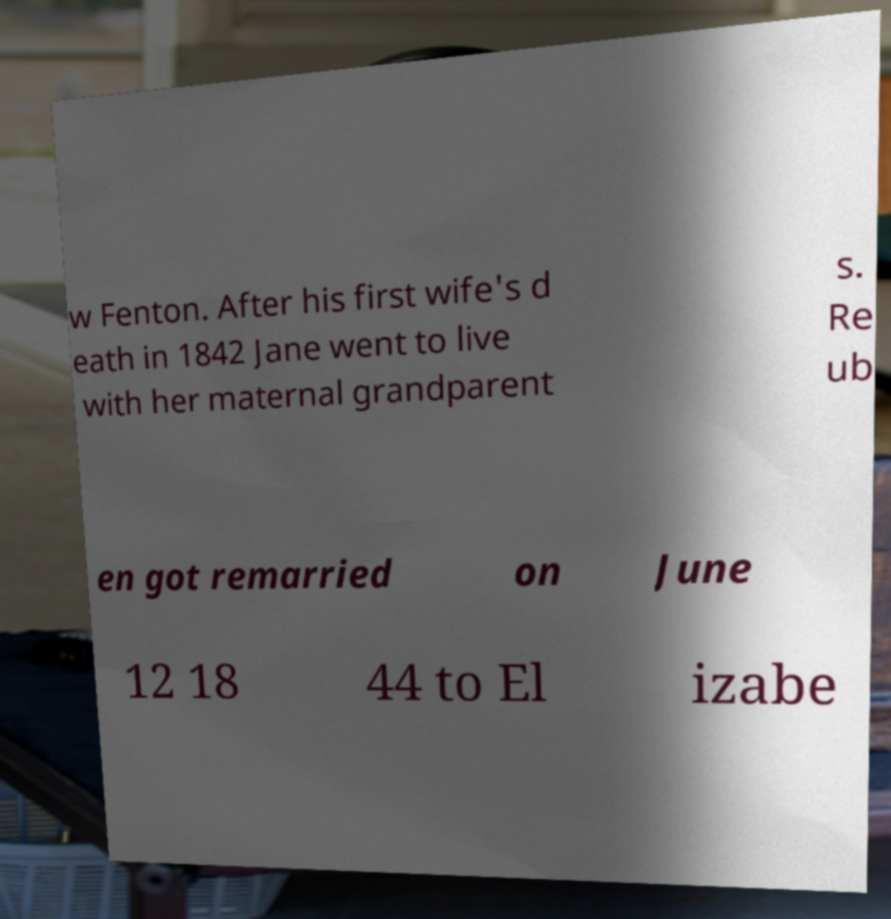Please identify and transcribe the text found in this image. w Fenton. After his first wife's d eath in 1842 Jane went to live with her maternal grandparent s. Re ub en got remarried on June 12 18 44 to El izabe 